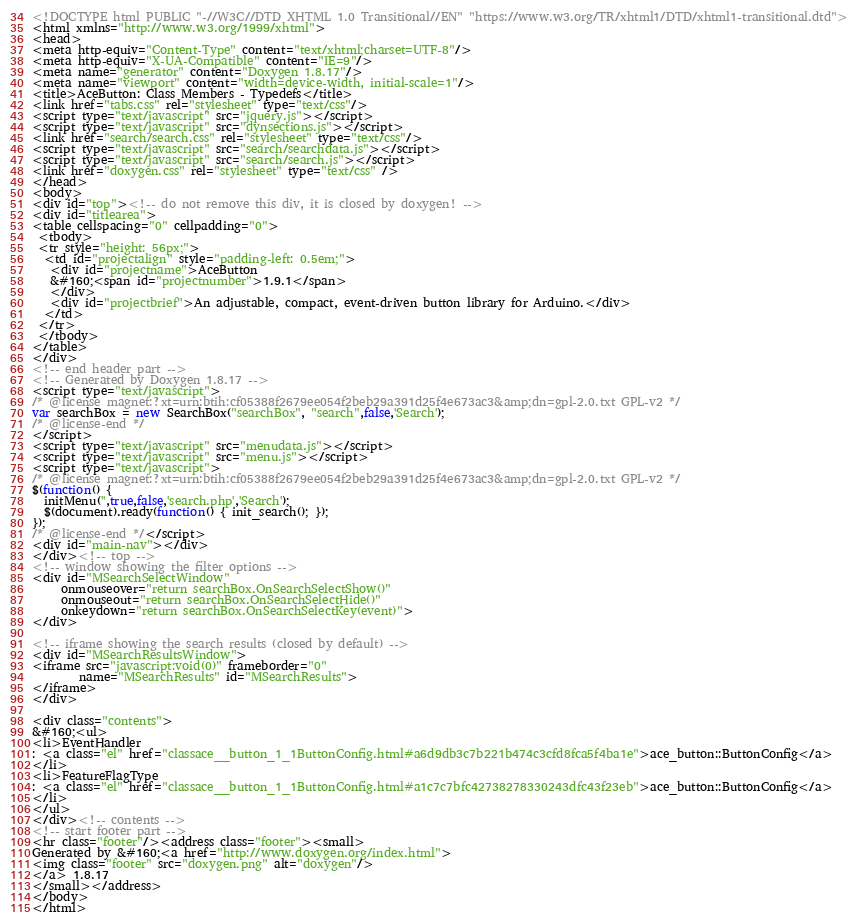Convert code to text. <code><loc_0><loc_0><loc_500><loc_500><_HTML_><!DOCTYPE html PUBLIC "-//W3C//DTD XHTML 1.0 Transitional//EN" "https://www.w3.org/TR/xhtml1/DTD/xhtml1-transitional.dtd">
<html xmlns="http://www.w3.org/1999/xhtml">
<head>
<meta http-equiv="Content-Type" content="text/xhtml;charset=UTF-8"/>
<meta http-equiv="X-UA-Compatible" content="IE=9"/>
<meta name="generator" content="Doxygen 1.8.17"/>
<meta name="viewport" content="width=device-width, initial-scale=1"/>
<title>AceButton: Class Members - Typedefs</title>
<link href="tabs.css" rel="stylesheet" type="text/css"/>
<script type="text/javascript" src="jquery.js"></script>
<script type="text/javascript" src="dynsections.js"></script>
<link href="search/search.css" rel="stylesheet" type="text/css"/>
<script type="text/javascript" src="search/searchdata.js"></script>
<script type="text/javascript" src="search/search.js"></script>
<link href="doxygen.css" rel="stylesheet" type="text/css" />
</head>
<body>
<div id="top"><!-- do not remove this div, it is closed by doxygen! -->
<div id="titlearea">
<table cellspacing="0" cellpadding="0">
 <tbody>
 <tr style="height: 56px;">
  <td id="projectalign" style="padding-left: 0.5em;">
   <div id="projectname">AceButton
   &#160;<span id="projectnumber">1.9.1</span>
   </div>
   <div id="projectbrief">An adjustable, compact, event-driven button library for Arduino.</div>
  </td>
 </tr>
 </tbody>
</table>
</div>
<!-- end header part -->
<!-- Generated by Doxygen 1.8.17 -->
<script type="text/javascript">
/* @license magnet:?xt=urn:btih:cf05388f2679ee054f2beb29a391d25f4e673ac3&amp;dn=gpl-2.0.txt GPL-v2 */
var searchBox = new SearchBox("searchBox", "search",false,'Search');
/* @license-end */
</script>
<script type="text/javascript" src="menudata.js"></script>
<script type="text/javascript" src="menu.js"></script>
<script type="text/javascript">
/* @license magnet:?xt=urn:btih:cf05388f2679ee054f2beb29a391d25f4e673ac3&amp;dn=gpl-2.0.txt GPL-v2 */
$(function() {
  initMenu('',true,false,'search.php','Search');
  $(document).ready(function() { init_search(); });
});
/* @license-end */</script>
<div id="main-nav"></div>
</div><!-- top -->
<!-- window showing the filter options -->
<div id="MSearchSelectWindow"
     onmouseover="return searchBox.OnSearchSelectShow()"
     onmouseout="return searchBox.OnSearchSelectHide()"
     onkeydown="return searchBox.OnSearchSelectKey(event)">
</div>

<!-- iframe showing the search results (closed by default) -->
<div id="MSearchResultsWindow">
<iframe src="javascript:void(0)" frameborder="0" 
        name="MSearchResults" id="MSearchResults">
</iframe>
</div>

<div class="contents">
&#160;<ul>
<li>EventHandler
: <a class="el" href="classace__button_1_1ButtonConfig.html#a6d9db3c7b221b474c3cfd8fca5f4ba1e">ace_button::ButtonConfig</a>
</li>
<li>FeatureFlagType
: <a class="el" href="classace__button_1_1ButtonConfig.html#a1c7c7bfc42738278330243dfc43f23eb">ace_button::ButtonConfig</a>
</li>
</ul>
</div><!-- contents -->
<!-- start footer part -->
<hr class="footer"/><address class="footer"><small>
Generated by &#160;<a href="http://www.doxygen.org/index.html">
<img class="footer" src="doxygen.png" alt="doxygen"/>
</a> 1.8.17
</small></address>
</body>
</html>
</code> 